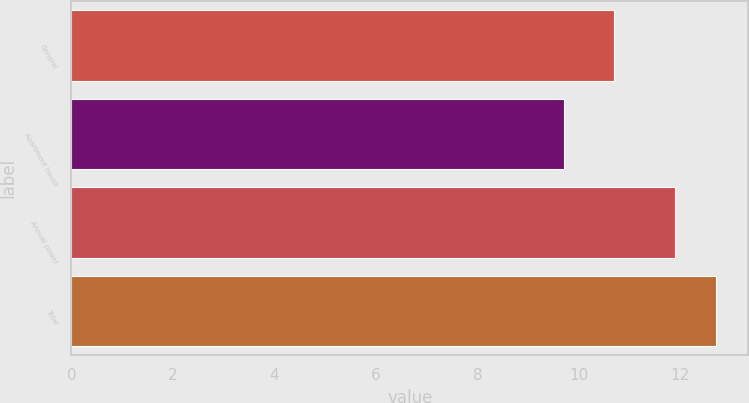Convert chart. <chart><loc_0><loc_0><loc_500><loc_500><bar_chart><fcel>General<fcel>Apartment house<fcel>Annual power<fcel>Total<nl><fcel>10.7<fcel>9.7<fcel>11.9<fcel>12.7<nl></chart> 